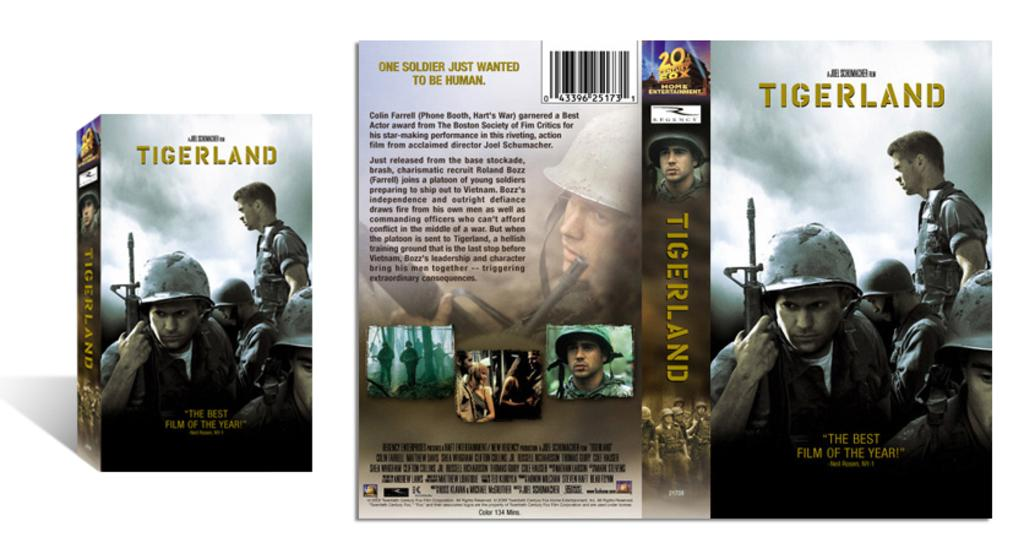<image>
Write a terse but informative summary of the picture. Box for a movie called The Tigerland showing soldiers on the cover. 